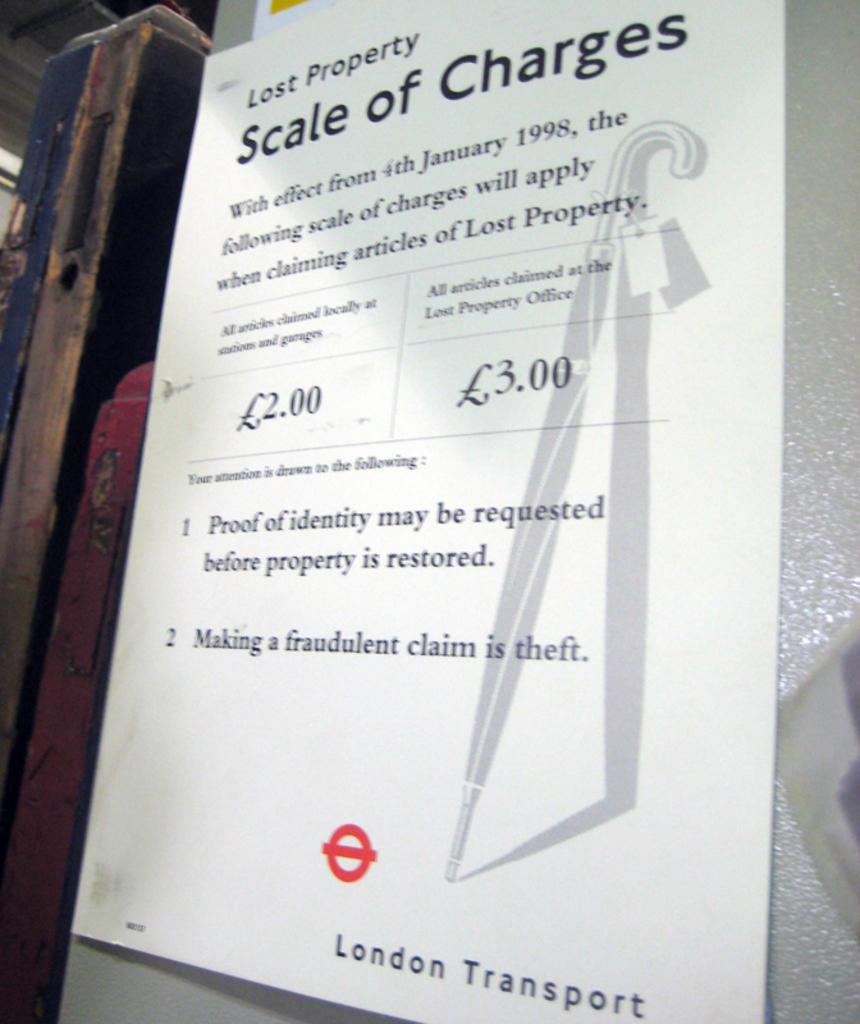<image>
Provide a brief description of the given image. A London Transport sign that is about lost property. 